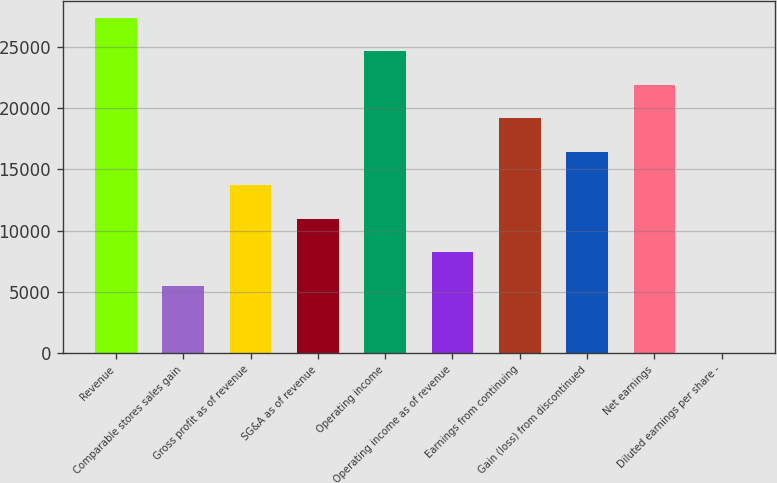Convert chart to OTSL. <chart><loc_0><loc_0><loc_500><loc_500><bar_chart><fcel>Revenue<fcel>Comparable stores sales gain<fcel>Gross profit as of revenue<fcel>SG&A as of revenue<fcel>Operating income<fcel>Operating income as of revenue<fcel>Earnings from continuing<fcel>Gain (loss) from discontinued<fcel>Net earnings<fcel>Diluted earnings per share -<nl><fcel>27433<fcel>5488.83<fcel>13717.9<fcel>10974.9<fcel>24690<fcel>8231.85<fcel>19203.9<fcel>16460.9<fcel>21947<fcel>2.79<nl></chart> 